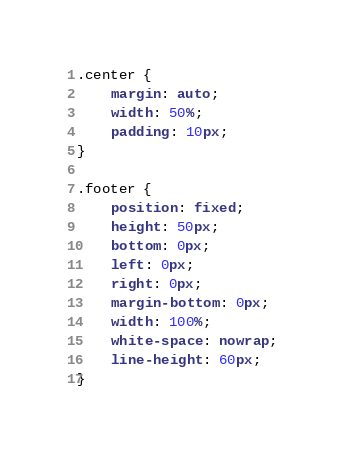<code> <loc_0><loc_0><loc_500><loc_500><_CSS_>.center {
    margin: auto;
    width: 50%;
    padding: 10px;
}

.footer {
    position: fixed; 
    height: 50px; 
    bottom: 0px; 
    left: 0px; 
    right: 0px; 
    margin-bottom: 0px; 
    width: 100%; 
    white-space: nowrap; 
    line-height: 60px;
}</code> 